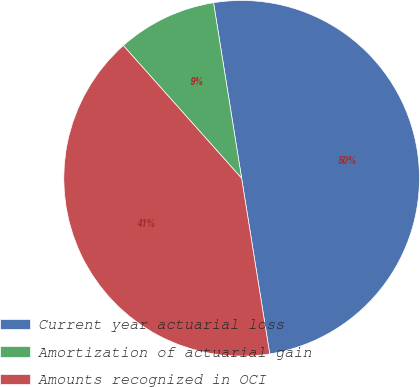<chart> <loc_0><loc_0><loc_500><loc_500><pie_chart><fcel>Current year actuarial loss<fcel>Amortization of actuarial gain<fcel>Amounts recognized in OCI<nl><fcel>50.0%<fcel>9.06%<fcel>40.94%<nl></chart> 